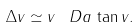Convert formula to latex. <formula><loc_0><loc_0><loc_500><loc_500>\Delta v \simeq v \, \ D a \, \tan v .</formula> 